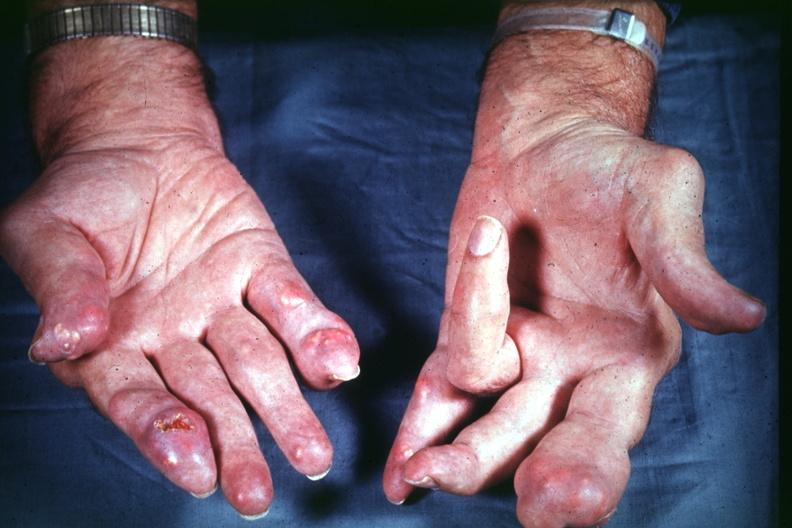s hand present?
Answer the question using a single word or phrase. Yes 